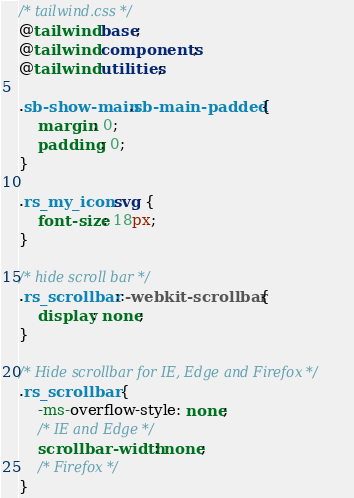<code> <loc_0><loc_0><loc_500><loc_500><_CSS_>/* tailwind.css */
@tailwind base;
@tailwind components;
@tailwind utilities;

.sb-show-main.sb-main-padded {
	margin: 0;
	padding: 0;
}

.rs_my_icon svg {
	font-size: 18px;
}

/* hide scroll bar */
.rs_scrollbar::-webkit-scrollbar {
	display: none;
}

/* Hide scrollbar for IE, Edge and Firefox */
.rs_scrollbar {
	-ms-overflow-style: none;
	/* IE and Edge */
	scrollbar-width: none;
	/* Firefox */
}</code> 